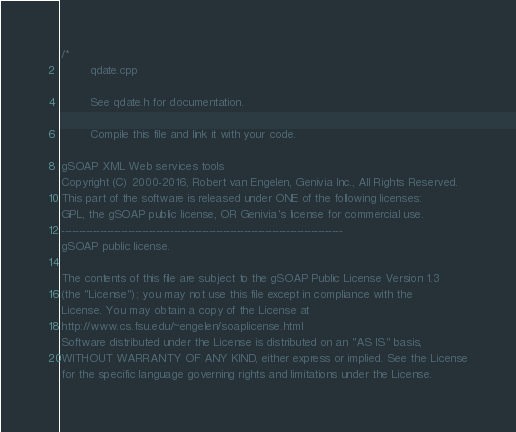Convert code to text. <code><loc_0><loc_0><loc_500><loc_500><_C++_>/*
        qdate.cpp

        See qdate.h for documentation.

        Compile this file and link it with your code.

gSOAP XML Web services tools
Copyright (C) 2000-2016, Robert van Engelen, Genivia Inc., All Rights Reserved.
This part of the software is released under ONE of the following licenses:
GPL, the gSOAP public license, OR Genivia's license for commercial use.
--------------------------------------------------------------------------------
gSOAP public license.

The contents of this file are subject to the gSOAP Public License Version 1.3
(the "License"); you may not use this file except in compliance with the
License. You may obtain a copy of the License at
http://www.cs.fsu.edu/~engelen/soaplicense.html
Software distributed under the License is distributed on an "AS IS" basis,
WITHOUT WARRANTY OF ANY KIND, either express or implied. See the License
for the specific language governing rights and limitations under the License.
</code> 